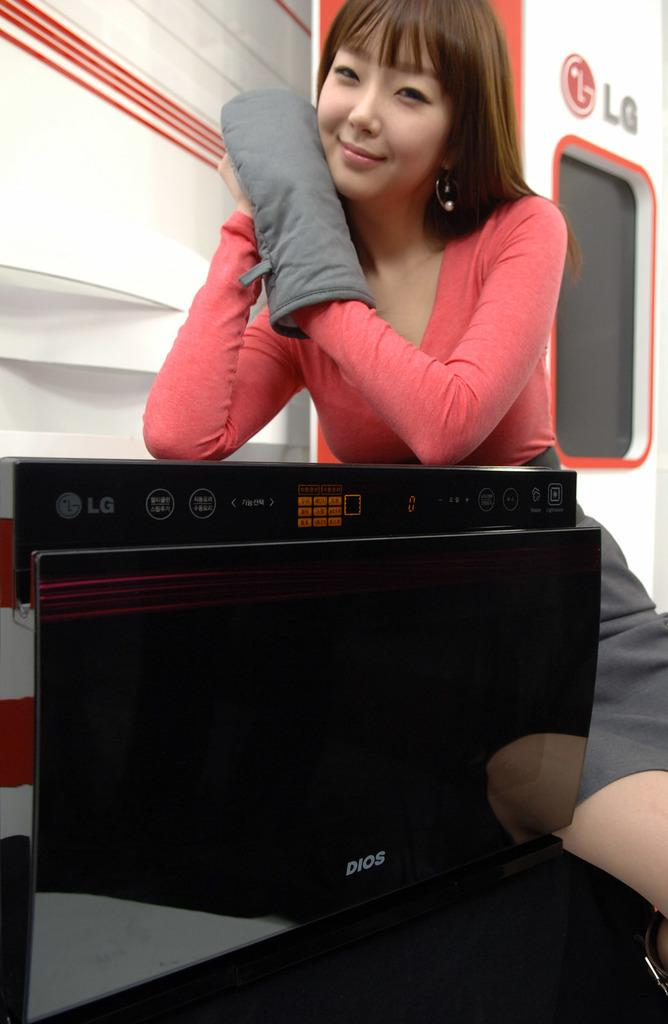<image>
Summarize the visual content of the image. A woman leans on a display of an LG appliance. 